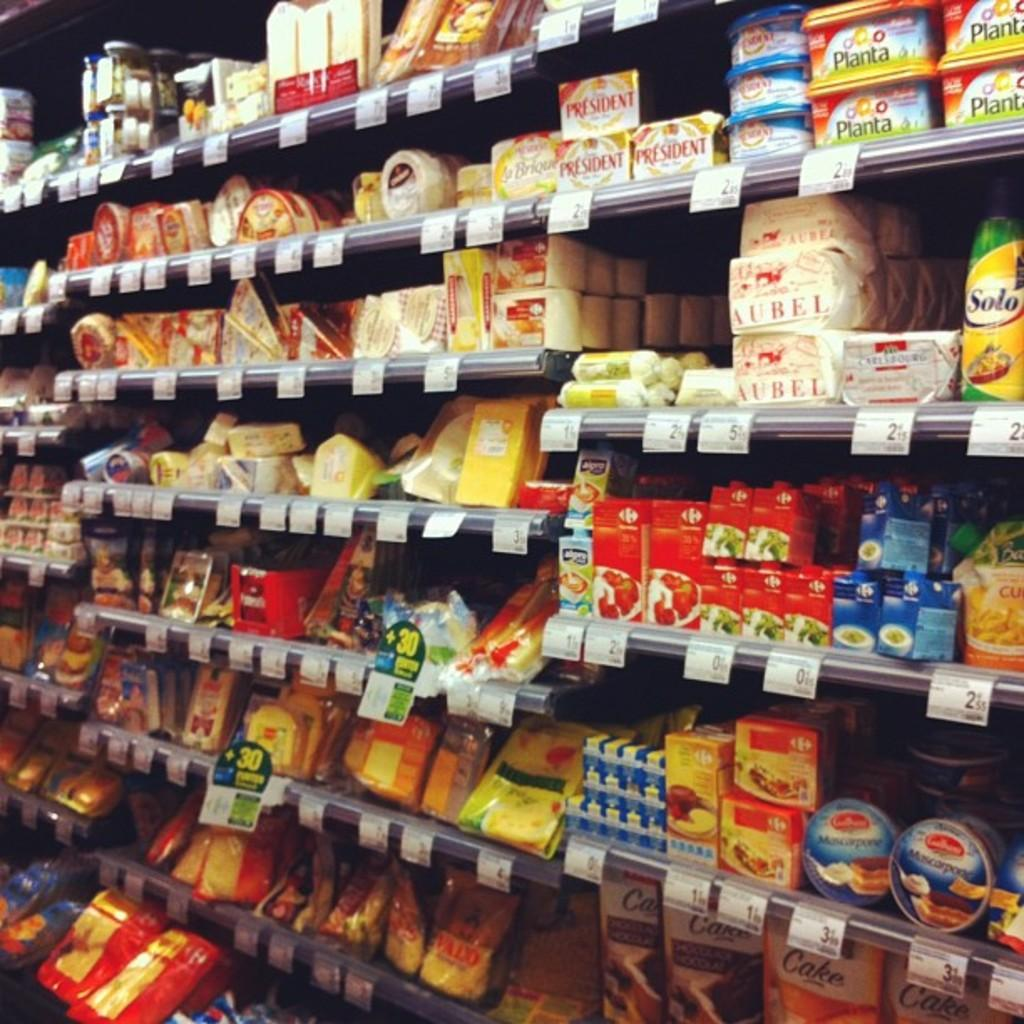What type of objects can be seen in the image? There are bottles and cardboard boxes in the image. What is the purpose of the covers on the rack in the image? The covers on the rack are likely used to protect or organize the items stored on the rack. Can you see a giraffe walking around in the image? No, there is no giraffe present in the image. Who is the writer of the book on the rack in the image? There is no book or writer mentioned in the provided facts about the image. 